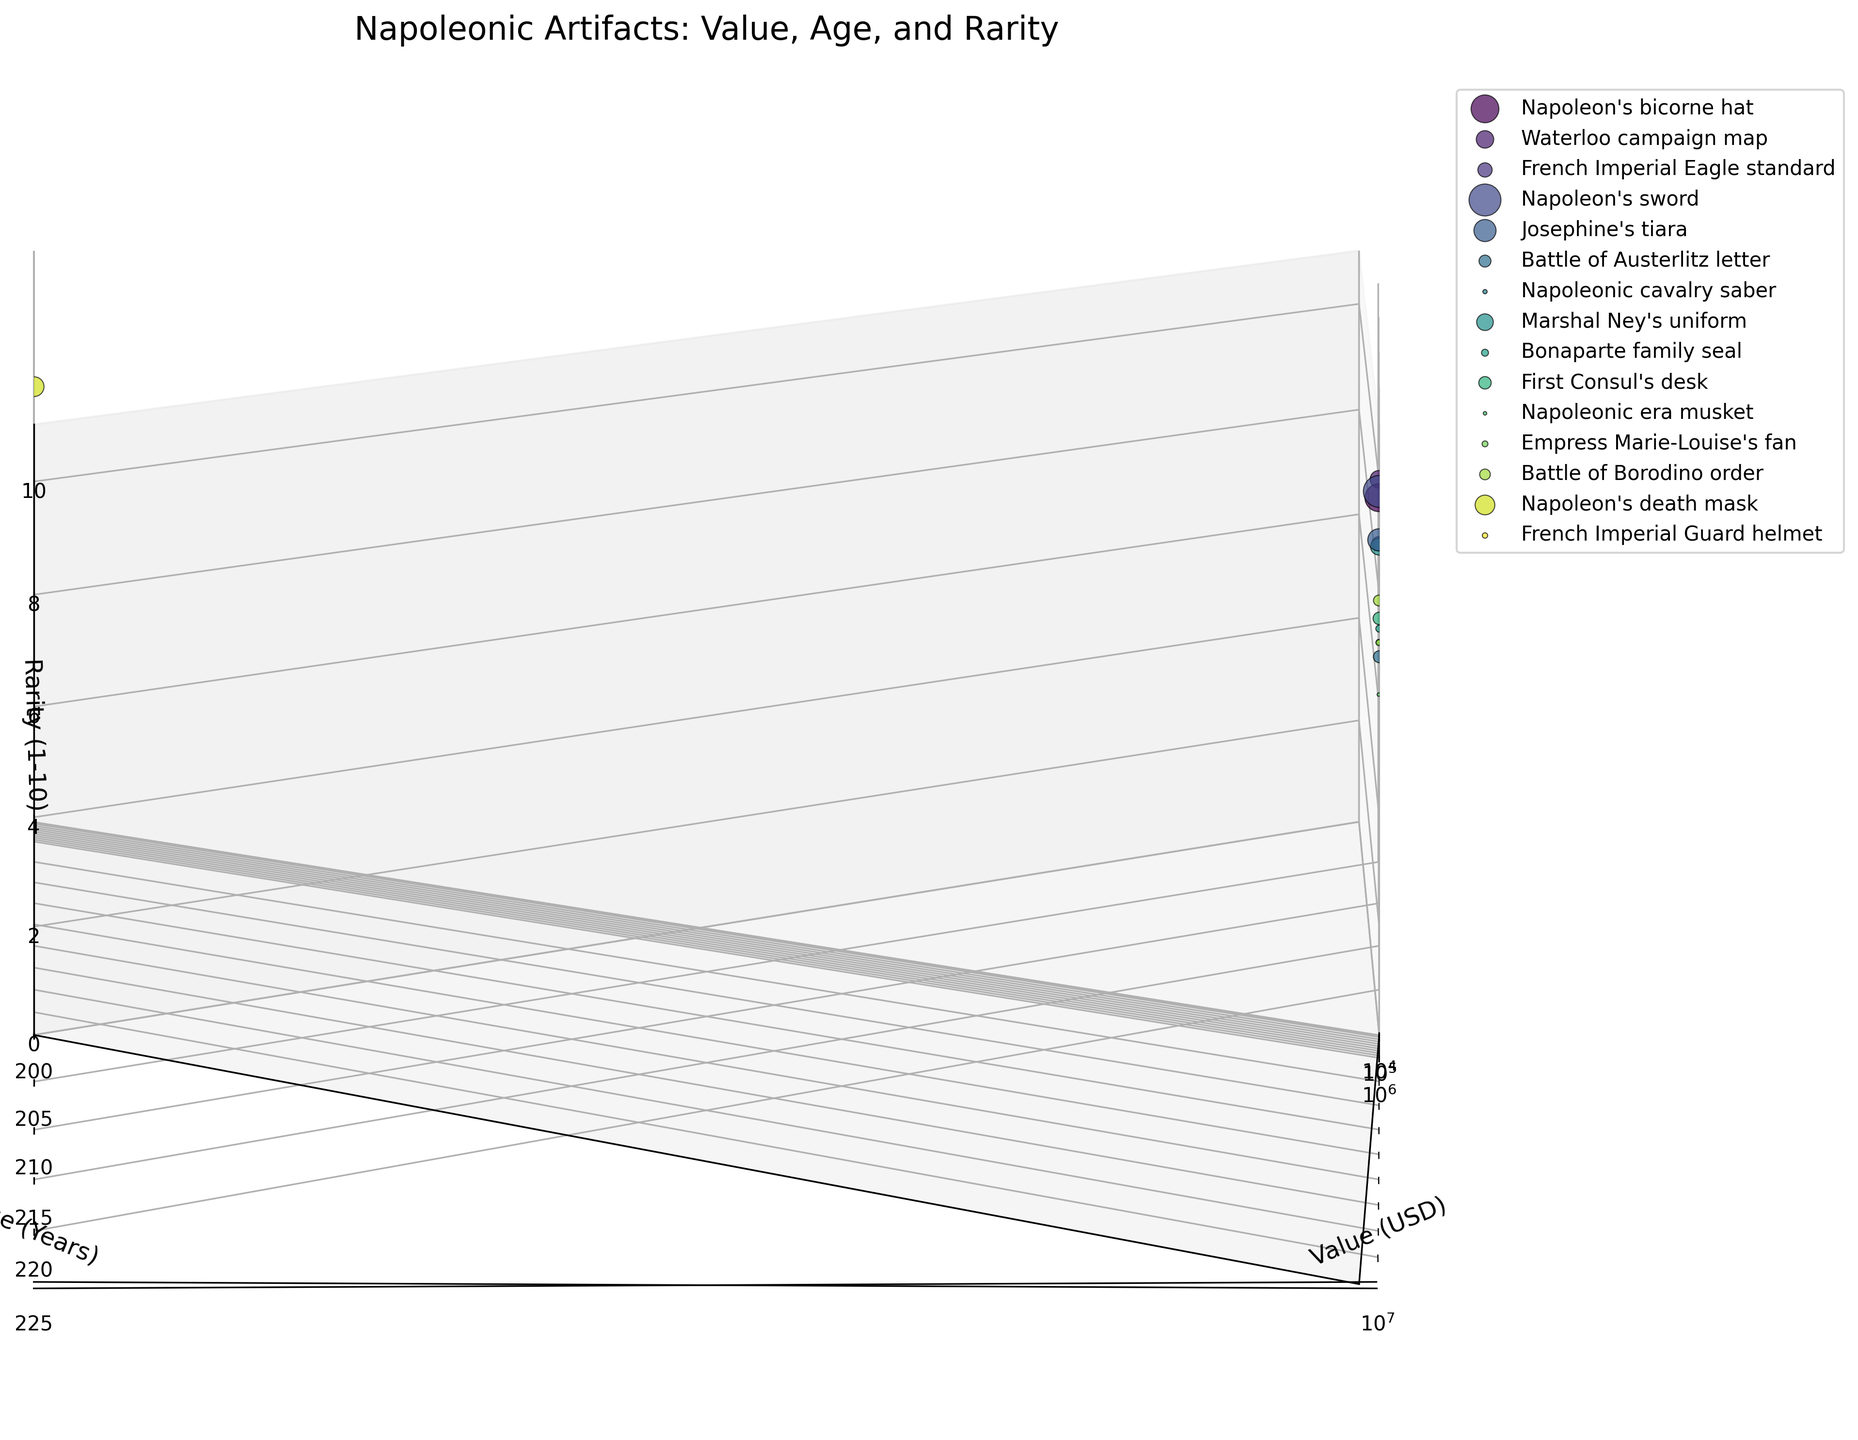what is the title of the figure? The title is typically located at the top of the figure and provides a brief overview of what the figure represents. The title for this particular figure is "Napoleonic Artifacts: Value, Age, and Rarity" as mentioned in the code.
Answer: Napoleonic Artifacts: Value, Age, and Rarity Which artifact is the oldest? By examining the 'Age (Years)' axis, we can identify the data point with the highest value. In this case, "Napoleon's sword" has an age of 220 years, making it the oldest artifact.
Answer: Napoleon's sword What is the most valuable artifact? By observing the 'Value (USD)' axis, we can see that "Napoleon's sword" has the highest value, which is $2,500,000.
Answer: Napoleon's sword How many categories of artifacts are compared in the plot? The plot labels each category with a different color. The distinct categories are represented in the legend. By counting the legend entries, we see that there are three categories: 'weapons', 'clothing', and 'documents'.
Answer: 3 Which artifact is the rarest? By inspecting the 'Rarity (1-10)' axis, the data point with the highest rarity score is 10. This corresponds to "Napoleon's sword".
Answer: Napoleon's sword Which artifact has the highest value among those aged around 210 years? By focusing on the 'Age (Years)' axis around 210 years and comparing the 'Value (USD)' values, "Marshal Ney's uniform" stands out with a value of $680,000.
Answer: Marshal Ney's uniform Compare the values of "Josephine's tiara" and "Napoleon's death mask". Which one is higher? By checking their 'Value (USD)' on the horizontal axis, "Josephine's tiara" is valued at $1,200,000, while "Napoleon's death mask" is valued at $950,000. Hence, "Josephine's tiara" has a higher value.
Answer: Josephine's tiara Are there any artifacts with a rarity score of 5? By examining the 'Rarity (1-10)' axis, we can see several data points aligned with the score of 5. Artifacts like "Napoleonic cavalry saber", "Empress Marie-Louise's fan", and "French Imperial Guard helmet" have a rarity score of 5.
Answer: Yes What is the least valuable artifact in the figure? By examining the 'Value (USD)' axis for the data point with the lowest value, we find "Napoleonic era musket" at $30,000.
Answer: Napoleonic era musket What is the difference in age between "Waterloo campaign map" and "Bonaparte family seal"? To find the difference, we look at their 'Age (Years)' values. "Waterloo campaign map" is 208 years old, and "Bonaparte family seal" is 215 years old. The difference is 215 - 208 = 7 years.
Answer: 7 years 